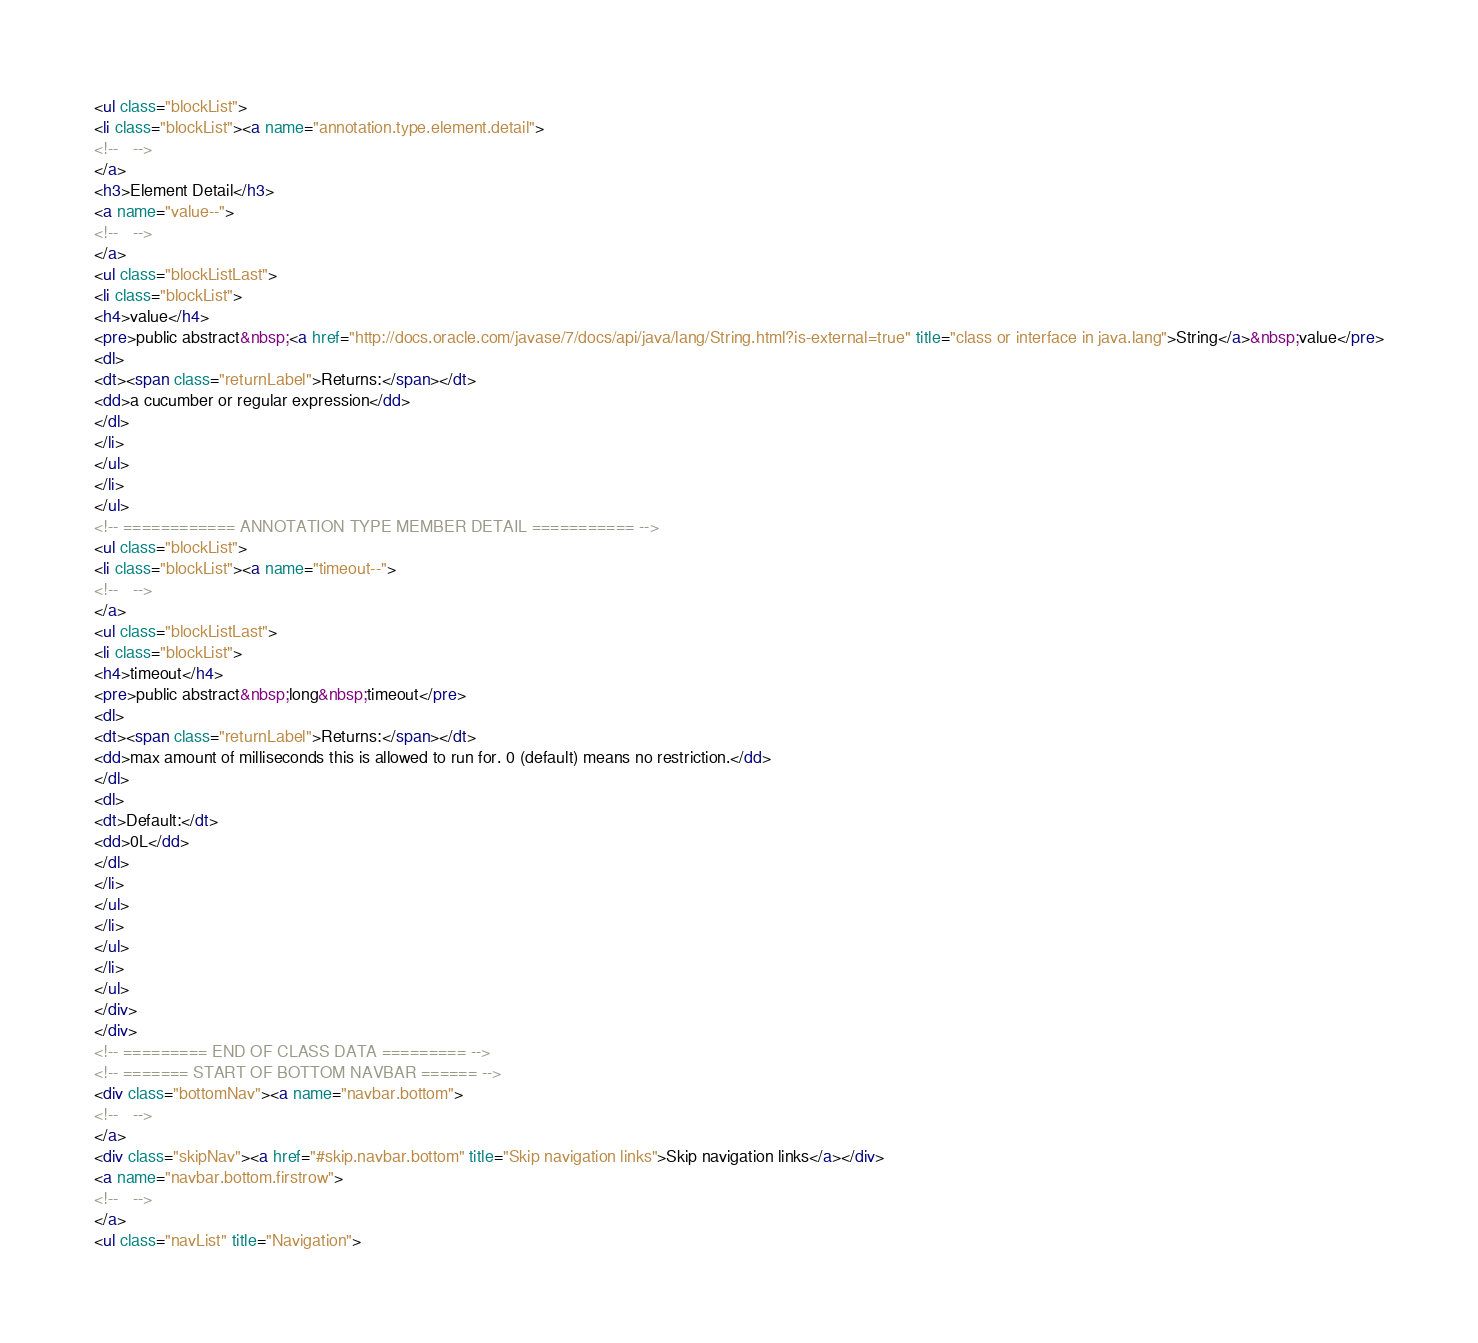<code> <loc_0><loc_0><loc_500><loc_500><_HTML_><ul class="blockList">
<li class="blockList"><a name="annotation.type.element.detail">
<!--   -->
</a>
<h3>Element Detail</h3>
<a name="value--">
<!--   -->
</a>
<ul class="blockListLast">
<li class="blockList">
<h4>value</h4>
<pre>public abstract&nbsp;<a href="http://docs.oracle.com/javase/7/docs/api/java/lang/String.html?is-external=true" title="class or interface in java.lang">String</a>&nbsp;value</pre>
<dl>
<dt><span class="returnLabel">Returns:</span></dt>
<dd>a cucumber or regular expression</dd>
</dl>
</li>
</ul>
</li>
</ul>
<!-- ============ ANNOTATION TYPE MEMBER DETAIL =========== -->
<ul class="blockList">
<li class="blockList"><a name="timeout--">
<!--   -->
</a>
<ul class="blockListLast">
<li class="blockList">
<h4>timeout</h4>
<pre>public abstract&nbsp;long&nbsp;timeout</pre>
<dl>
<dt><span class="returnLabel">Returns:</span></dt>
<dd>max amount of milliseconds this is allowed to run for. 0 (default) means no restriction.</dd>
</dl>
<dl>
<dt>Default:</dt>
<dd>0L</dd>
</dl>
</li>
</ul>
</li>
</ul>
</li>
</ul>
</div>
</div>
<!-- ========= END OF CLASS DATA ========= -->
<!-- ======= START OF BOTTOM NAVBAR ====== -->
<div class="bottomNav"><a name="navbar.bottom">
<!--   -->
</a>
<div class="skipNav"><a href="#skip.navbar.bottom" title="Skip navigation links">Skip navigation links</a></div>
<a name="navbar.bottom.firstrow">
<!--   -->
</a>
<ul class="navList" title="Navigation"></code> 